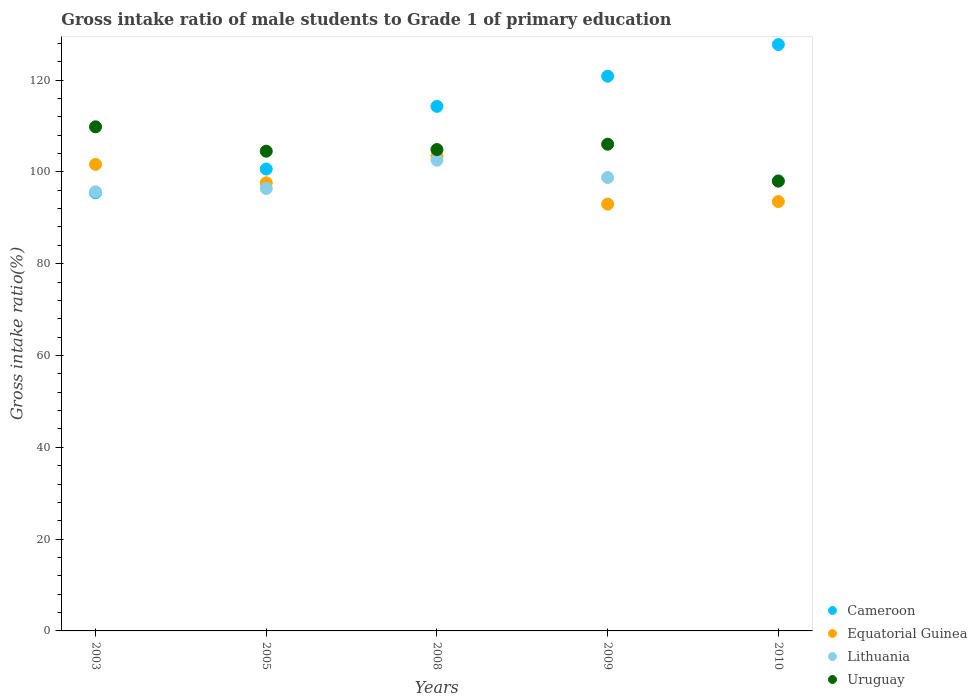How many different coloured dotlines are there?
Keep it short and to the point. 4. Is the number of dotlines equal to the number of legend labels?
Keep it short and to the point. Yes. What is the gross intake ratio in Cameroon in 2009?
Offer a very short reply. 120.85. Across all years, what is the maximum gross intake ratio in Cameroon?
Give a very brief answer. 127.74. Across all years, what is the minimum gross intake ratio in Uruguay?
Make the answer very short. 97.98. In which year was the gross intake ratio in Equatorial Guinea maximum?
Ensure brevity in your answer.  2008. In which year was the gross intake ratio in Uruguay minimum?
Your response must be concise. 2010. What is the total gross intake ratio in Cameroon in the graph?
Your answer should be very brief. 558.94. What is the difference between the gross intake ratio in Lithuania in 2008 and that in 2009?
Provide a short and direct response. 3.78. What is the difference between the gross intake ratio in Lithuania in 2005 and the gross intake ratio in Equatorial Guinea in 2010?
Provide a succinct answer. 2.85. What is the average gross intake ratio in Uruguay per year?
Keep it short and to the point. 104.64. In the year 2010, what is the difference between the gross intake ratio in Equatorial Guinea and gross intake ratio in Uruguay?
Provide a short and direct response. -4.45. In how many years, is the gross intake ratio in Lithuania greater than 80 %?
Your response must be concise. 5. What is the ratio of the gross intake ratio in Equatorial Guinea in 2008 to that in 2009?
Your answer should be compact. 1.11. Is the gross intake ratio in Uruguay in 2003 less than that in 2009?
Make the answer very short. No. Is the difference between the gross intake ratio in Equatorial Guinea in 2005 and 2008 greater than the difference between the gross intake ratio in Uruguay in 2005 and 2008?
Keep it short and to the point. No. What is the difference between the highest and the second highest gross intake ratio in Lithuania?
Keep it short and to the point. 3.78. What is the difference between the highest and the lowest gross intake ratio in Equatorial Guinea?
Offer a very short reply. 10.49. In how many years, is the gross intake ratio in Uruguay greater than the average gross intake ratio in Uruguay taken over all years?
Ensure brevity in your answer.  3. Is the sum of the gross intake ratio in Cameroon in 2003 and 2009 greater than the maximum gross intake ratio in Equatorial Guinea across all years?
Give a very brief answer. Yes. Is it the case that in every year, the sum of the gross intake ratio in Uruguay and gross intake ratio in Lithuania  is greater than the sum of gross intake ratio in Cameroon and gross intake ratio in Equatorial Guinea?
Your answer should be very brief. No. Is it the case that in every year, the sum of the gross intake ratio in Lithuania and gross intake ratio in Uruguay  is greater than the gross intake ratio in Cameroon?
Make the answer very short. Yes. How many dotlines are there?
Give a very brief answer. 4. Are the values on the major ticks of Y-axis written in scientific E-notation?
Your answer should be compact. No. Does the graph contain any zero values?
Ensure brevity in your answer.  No. Does the graph contain grids?
Your response must be concise. No. Where does the legend appear in the graph?
Make the answer very short. Bottom right. How many legend labels are there?
Offer a very short reply. 4. What is the title of the graph?
Offer a very short reply. Gross intake ratio of male students to Grade 1 of primary education. What is the label or title of the X-axis?
Offer a very short reply. Years. What is the label or title of the Y-axis?
Keep it short and to the point. Gross intake ratio(%). What is the Gross intake ratio(%) of Cameroon in 2003?
Keep it short and to the point. 95.46. What is the Gross intake ratio(%) of Equatorial Guinea in 2003?
Offer a terse response. 101.63. What is the Gross intake ratio(%) in Lithuania in 2003?
Your answer should be compact. 95.67. What is the Gross intake ratio(%) of Uruguay in 2003?
Your response must be concise. 109.82. What is the Gross intake ratio(%) in Cameroon in 2005?
Provide a short and direct response. 100.62. What is the Gross intake ratio(%) of Equatorial Guinea in 2005?
Give a very brief answer. 97.62. What is the Gross intake ratio(%) in Lithuania in 2005?
Give a very brief answer. 96.38. What is the Gross intake ratio(%) in Uruguay in 2005?
Provide a short and direct response. 104.5. What is the Gross intake ratio(%) in Cameroon in 2008?
Ensure brevity in your answer.  114.27. What is the Gross intake ratio(%) of Equatorial Guinea in 2008?
Ensure brevity in your answer.  103.47. What is the Gross intake ratio(%) in Lithuania in 2008?
Ensure brevity in your answer.  102.55. What is the Gross intake ratio(%) of Uruguay in 2008?
Your answer should be very brief. 104.86. What is the Gross intake ratio(%) of Cameroon in 2009?
Your response must be concise. 120.85. What is the Gross intake ratio(%) in Equatorial Guinea in 2009?
Offer a terse response. 92.97. What is the Gross intake ratio(%) of Lithuania in 2009?
Offer a terse response. 98.77. What is the Gross intake ratio(%) in Uruguay in 2009?
Make the answer very short. 106.03. What is the Gross intake ratio(%) of Cameroon in 2010?
Ensure brevity in your answer.  127.74. What is the Gross intake ratio(%) of Equatorial Guinea in 2010?
Ensure brevity in your answer.  93.54. What is the Gross intake ratio(%) in Lithuania in 2010?
Your answer should be compact. 98.09. What is the Gross intake ratio(%) of Uruguay in 2010?
Make the answer very short. 97.98. Across all years, what is the maximum Gross intake ratio(%) of Cameroon?
Offer a terse response. 127.74. Across all years, what is the maximum Gross intake ratio(%) of Equatorial Guinea?
Give a very brief answer. 103.47. Across all years, what is the maximum Gross intake ratio(%) of Lithuania?
Provide a short and direct response. 102.55. Across all years, what is the maximum Gross intake ratio(%) in Uruguay?
Keep it short and to the point. 109.82. Across all years, what is the minimum Gross intake ratio(%) of Cameroon?
Offer a very short reply. 95.46. Across all years, what is the minimum Gross intake ratio(%) in Equatorial Guinea?
Provide a succinct answer. 92.97. Across all years, what is the minimum Gross intake ratio(%) of Lithuania?
Give a very brief answer. 95.67. Across all years, what is the minimum Gross intake ratio(%) in Uruguay?
Offer a terse response. 97.98. What is the total Gross intake ratio(%) in Cameroon in the graph?
Provide a succinct answer. 558.94. What is the total Gross intake ratio(%) in Equatorial Guinea in the graph?
Your answer should be very brief. 489.22. What is the total Gross intake ratio(%) of Lithuania in the graph?
Your response must be concise. 491.46. What is the total Gross intake ratio(%) of Uruguay in the graph?
Offer a terse response. 523.2. What is the difference between the Gross intake ratio(%) in Cameroon in 2003 and that in 2005?
Offer a terse response. -5.16. What is the difference between the Gross intake ratio(%) of Equatorial Guinea in 2003 and that in 2005?
Provide a succinct answer. 4.01. What is the difference between the Gross intake ratio(%) in Lithuania in 2003 and that in 2005?
Provide a short and direct response. -0.71. What is the difference between the Gross intake ratio(%) of Uruguay in 2003 and that in 2005?
Your answer should be very brief. 5.31. What is the difference between the Gross intake ratio(%) of Cameroon in 2003 and that in 2008?
Ensure brevity in your answer.  -18.81. What is the difference between the Gross intake ratio(%) in Equatorial Guinea in 2003 and that in 2008?
Your answer should be compact. -1.84. What is the difference between the Gross intake ratio(%) in Lithuania in 2003 and that in 2008?
Give a very brief answer. -6.88. What is the difference between the Gross intake ratio(%) of Uruguay in 2003 and that in 2008?
Give a very brief answer. 4.95. What is the difference between the Gross intake ratio(%) of Cameroon in 2003 and that in 2009?
Your answer should be compact. -25.38. What is the difference between the Gross intake ratio(%) in Equatorial Guinea in 2003 and that in 2009?
Give a very brief answer. 8.65. What is the difference between the Gross intake ratio(%) in Lithuania in 2003 and that in 2009?
Provide a succinct answer. -3.1. What is the difference between the Gross intake ratio(%) of Uruguay in 2003 and that in 2009?
Provide a short and direct response. 3.79. What is the difference between the Gross intake ratio(%) of Cameroon in 2003 and that in 2010?
Keep it short and to the point. -32.28. What is the difference between the Gross intake ratio(%) of Equatorial Guinea in 2003 and that in 2010?
Provide a succinct answer. 8.09. What is the difference between the Gross intake ratio(%) in Lithuania in 2003 and that in 2010?
Provide a succinct answer. -2.42. What is the difference between the Gross intake ratio(%) in Uruguay in 2003 and that in 2010?
Your answer should be very brief. 11.83. What is the difference between the Gross intake ratio(%) of Cameroon in 2005 and that in 2008?
Ensure brevity in your answer.  -13.65. What is the difference between the Gross intake ratio(%) in Equatorial Guinea in 2005 and that in 2008?
Provide a succinct answer. -5.85. What is the difference between the Gross intake ratio(%) of Lithuania in 2005 and that in 2008?
Provide a succinct answer. -6.17. What is the difference between the Gross intake ratio(%) of Uruguay in 2005 and that in 2008?
Provide a succinct answer. -0.36. What is the difference between the Gross intake ratio(%) of Cameroon in 2005 and that in 2009?
Provide a short and direct response. -20.22. What is the difference between the Gross intake ratio(%) of Equatorial Guinea in 2005 and that in 2009?
Make the answer very short. 4.64. What is the difference between the Gross intake ratio(%) in Lithuania in 2005 and that in 2009?
Ensure brevity in your answer.  -2.39. What is the difference between the Gross intake ratio(%) of Uruguay in 2005 and that in 2009?
Give a very brief answer. -1.52. What is the difference between the Gross intake ratio(%) in Cameroon in 2005 and that in 2010?
Your response must be concise. -27.12. What is the difference between the Gross intake ratio(%) of Equatorial Guinea in 2005 and that in 2010?
Offer a very short reply. 4.08. What is the difference between the Gross intake ratio(%) in Lithuania in 2005 and that in 2010?
Offer a terse response. -1.71. What is the difference between the Gross intake ratio(%) in Uruguay in 2005 and that in 2010?
Your answer should be very brief. 6.52. What is the difference between the Gross intake ratio(%) in Cameroon in 2008 and that in 2009?
Offer a terse response. -6.58. What is the difference between the Gross intake ratio(%) in Equatorial Guinea in 2008 and that in 2009?
Your answer should be compact. 10.49. What is the difference between the Gross intake ratio(%) of Lithuania in 2008 and that in 2009?
Keep it short and to the point. 3.78. What is the difference between the Gross intake ratio(%) of Uruguay in 2008 and that in 2009?
Provide a succinct answer. -1.16. What is the difference between the Gross intake ratio(%) in Cameroon in 2008 and that in 2010?
Your response must be concise. -13.47. What is the difference between the Gross intake ratio(%) in Equatorial Guinea in 2008 and that in 2010?
Provide a short and direct response. 9.93. What is the difference between the Gross intake ratio(%) in Lithuania in 2008 and that in 2010?
Keep it short and to the point. 4.46. What is the difference between the Gross intake ratio(%) in Uruguay in 2008 and that in 2010?
Your answer should be compact. 6.88. What is the difference between the Gross intake ratio(%) in Cameroon in 2009 and that in 2010?
Your answer should be compact. -6.89. What is the difference between the Gross intake ratio(%) of Equatorial Guinea in 2009 and that in 2010?
Your answer should be compact. -0.56. What is the difference between the Gross intake ratio(%) in Lithuania in 2009 and that in 2010?
Make the answer very short. 0.68. What is the difference between the Gross intake ratio(%) of Uruguay in 2009 and that in 2010?
Offer a very short reply. 8.04. What is the difference between the Gross intake ratio(%) in Cameroon in 2003 and the Gross intake ratio(%) in Equatorial Guinea in 2005?
Your response must be concise. -2.16. What is the difference between the Gross intake ratio(%) in Cameroon in 2003 and the Gross intake ratio(%) in Lithuania in 2005?
Offer a very short reply. -0.92. What is the difference between the Gross intake ratio(%) of Cameroon in 2003 and the Gross intake ratio(%) of Uruguay in 2005?
Make the answer very short. -9.04. What is the difference between the Gross intake ratio(%) of Equatorial Guinea in 2003 and the Gross intake ratio(%) of Lithuania in 2005?
Offer a terse response. 5.25. What is the difference between the Gross intake ratio(%) of Equatorial Guinea in 2003 and the Gross intake ratio(%) of Uruguay in 2005?
Provide a short and direct response. -2.88. What is the difference between the Gross intake ratio(%) in Lithuania in 2003 and the Gross intake ratio(%) in Uruguay in 2005?
Make the answer very short. -8.83. What is the difference between the Gross intake ratio(%) in Cameroon in 2003 and the Gross intake ratio(%) in Equatorial Guinea in 2008?
Ensure brevity in your answer.  -8. What is the difference between the Gross intake ratio(%) of Cameroon in 2003 and the Gross intake ratio(%) of Lithuania in 2008?
Your response must be concise. -7.09. What is the difference between the Gross intake ratio(%) in Cameroon in 2003 and the Gross intake ratio(%) in Uruguay in 2008?
Your answer should be very brief. -9.4. What is the difference between the Gross intake ratio(%) in Equatorial Guinea in 2003 and the Gross intake ratio(%) in Lithuania in 2008?
Provide a short and direct response. -0.92. What is the difference between the Gross intake ratio(%) of Equatorial Guinea in 2003 and the Gross intake ratio(%) of Uruguay in 2008?
Offer a terse response. -3.24. What is the difference between the Gross intake ratio(%) of Lithuania in 2003 and the Gross intake ratio(%) of Uruguay in 2008?
Your answer should be very brief. -9.19. What is the difference between the Gross intake ratio(%) of Cameroon in 2003 and the Gross intake ratio(%) of Equatorial Guinea in 2009?
Offer a very short reply. 2.49. What is the difference between the Gross intake ratio(%) of Cameroon in 2003 and the Gross intake ratio(%) of Lithuania in 2009?
Ensure brevity in your answer.  -3.31. What is the difference between the Gross intake ratio(%) of Cameroon in 2003 and the Gross intake ratio(%) of Uruguay in 2009?
Provide a short and direct response. -10.57. What is the difference between the Gross intake ratio(%) of Equatorial Guinea in 2003 and the Gross intake ratio(%) of Lithuania in 2009?
Give a very brief answer. 2.86. What is the difference between the Gross intake ratio(%) in Equatorial Guinea in 2003 and the Gross intake ratio(%) in Uruguay in 2009?
Provide a succinct answer. -4.4. What is the difference between the Gross intake ratio(%) of Lithuania in 2003 and the Gross intake ratio(%) of Uruguay in 2009?
Ensure brevity in your answer.  -10.36. What is the difference between the Gross intake ratio(%) of Cameroon in 2003 and the Gross intake ratio(%) of Equatorial Guinea in 2010?
Keep it short and to the point. 1.93. What is the difference between the Gross intake ratio(%) of Cameroon in 2003 and the Gross intake ratio(%) of Lithuania in 2010?
Provide a short and direct response. -2.62. What is the difference between the Gross intake ratio(%) in Cameroon in 2003 and the Gross intake ratio(%) in Uruguay in 2010?
Give a very brief answer. -2.52. What is the difference between the Gross intake ratio(%) in Equatorial Guinea in 2003 and the Gross intake ratio(%) in Lithuania in 2010?
Provide a succinct answer. 3.54. What is the difference between the Gross intake ratio(%) of Equatorial Guinea in 2003 and the Gross intake ratio(%) of Uruguay in 2010?
Make the answer very short. 3.64. What is the difference between the Gross intake ratio(%) of Lithuania in 2003 and the Gross intake ratio(%) of Uruguay in 2010?
Offer a very short reply. -2.31. What is the difference between the Gross intake ratio(%) of Cameroon in 2005 and the Gross intake ratio(%) of Equatorial Guinea in 2008?
Your answer should be very brief. -2.85. What is the difference between the Gross intake ratio(%) in Cameroon in 2005 and the Gross intake ratio(%) in Lithuania in 2008?
Provide a succinct answer. -1.93. What is the difference between the Gross intake ratio(%) of Cameroon in 2005 and the Gross intake ratio(%) of Uruguay in 2008?
Your response must be concise. -4.24. What is the difference between the Gross intake ratio(%) of Equatorial Guinea in 2005 and the Gross intake ratio(%) of Lithuania in 2008?
Provide a short and direct response. -4.93. What is the difference between the Gross intake ratio(%) of Equatorial Guinea in 2005 and the Gross intake ratio(%) of Uruguay in 2008?
Your response must be concise. -7.25. What is the difference between the Gross intake ratio(%) in Lithuania in 2005 and the Gross intake ratio(%) in Uruguay in 2008?
Offer a very short reply. -8.48. What is the difference between the Gross intake ratio(%) in Cameroon in 2005 and the Gross intake ratio(%) in Equatorial Guinea in 2009?
Provide a short and direct response. 7.65. What is the difference between the Gross intake ratio(%) in Cameroon in 2005 and the Gross intake ratio(%) in Lithuania in 2009?
Keep it short and to the point. 1.85. What is the difference between the Gross intake ratio(%) in Cameroon in 2005 and the Gross intake ratio(%) in Uruguay in 2009?
Give a very brief answer. -5.41. What is the difference between the Gross intake ratio(%) in Equatorial Guinea in 2005 and the Gross intake ratio(%) in Lithuania in 2009?
Give a very brief answer. -1.15. What is the difference between the Gross intake ratio(%) of Equatorial Guinea in 2005 and the Gross intake ratio(%) of Uruguay in 2009?
Provide a succinct answer. -8.41. What is the difference between the Gross intake ratio(%) in Lithuania in 2005 and the Gross intake ratio(%) in Uruguay in 2009?
Your response must be concise. -9.65. What is the difference between the Gross intake ratio(%) of Cameroon in 2005 and the Gross intake ratio(%) of Equatorial Guinea in 2010?
Provide a short and direct response. 7.09. What is the difference between the Gross intake ratio(%) in Cameroon in 2005 and the Gross intake ratio(%) in Lithuania in 2010?
Offer a very short reply. 2.53. What is the difference between the Gross intake ratio(%) in Cameroon in 2005 and the Gross intake ratio(%) in Uruguay in 2010?
Give a very brief answer. 2.64. What is the difference between the Gross intake ratio(%) in Equatorial Guinea in 2005 and the Gross intake ratio(%) in Lithuania in 2010?
Your response must be concise. -0.47. What is the difference between the Gross intake ratio(%) of Equatorial Guinea in 2005 and the Gross intake ratio(%) of Uruguay in 2010?
Offer a very short reply. -0.36. What is the difference between the Gross intake ratio(%) in Lithuania in 2005 and the Gross intake ratio(%) in Uruguay in 2010?
Offer a terse response. -1.6. What is the difference between the Gross intake ratio(%) of Cameroon in 2008 and the Gross intake ratio(%) of Equatorial Guinea in 2009?
Provide a succinct answer. 21.29. What is the difference between the Gross intake ratio(%) in Cameroon in 2008 and the Gross intake ratio(%) in Lithuania in 2009?
Offer a terse response. 15.5. What is the difference between the Gross intake ratio(%) in Cameroon in 2008 and the Gross intake ratio(%) in Uruguay in 2009?
Your answer should be very brief. 8.24. What is the difference between the Gross intake ratio(%) in Equatorial Guinea in 2008 and the Gross intake ratio(%) in Lithuania in 2009?
Provide a short and direct response. 4.7. What is the difference between the Gross intake ratio(%) in Equatorial Guinea in 2008 and the Gross intake ratio(%) in Uruguay in 2009?
Keep it short and to the point. -2.56. What is the difference between the Gross intake ratio(%) in Lithuania in 2008 and the Gross intake ratio(%) in Uruguay in 2009?
Keep it short and to the point. -3.48. What is the difference between the Gross intake ratio(%) in Cameroon in 2008 and the Gross intake ratio(%) in Equatorial Guinea in 2010?
Offer a terse response. 20.73. What is the difference between the Gross intake ratio(%) in Cameroon in 2008 and the Gross intake ratio(%) in Lithuania in 2010?
Your answer should be very brief. 16.18. What is the difference between the Gross intake ratio(%) of Cameroon in 2008 and the Gross intake ratio(%) of Uruguay in 2010?
Your answer should be compact. 16.29. What is the difference between the Gross intake ratio(%) in Equatorial Guinea in 2008 and the Gross intake ratio(%) in Lithuania in 2010?
Offer a very short reply. 5.38. What is the difference between the Gross intake ratio(%) in Equatorial Guinea in 2008 and the Gross intake ratio(%) in Uruguay in 2010?
Make the answer very short. 5.48. What is the difference between the Gross intake ratio(%) in Lithuania in 2008 and the Gross intake ratio(%) in Uruguay in 2010?
Keep it short and to the point. 4.57. What is the difference between the Gross intake ratio(%) of Cameroon in 2009 and the Gross intake ratio(%) of Equatorial Guinea in 2010?
Provide a succinct answer. 27.31. What is the difference between the Gross intake ratio(%) of Cameroon in 2009 and the Gross intake ratio(%) of Lithuania in 2010?
Provide a short and direct response. 22.76. What is the difference between the Gross intake ratio(%) of Cameroon in 2009 and the Gross intake ratio(%) of Uruguay in 2010?
Provide a succinct answer. 22.86. What is the difference between the Gross intake ratio(%) of Equatorial Guinea in 2009 and the Gross intake ratio(%) of Lithuania in 2010?
Provide a succinct answer. -5.11. What is the difference between the Gross intake ratio(%) in Equatorial Guinea in 2009 and the Gross intake ratio(%) in Uruguay in 2010?
Ensure brevity in your answer.  -5.01. What is the difference between the Gross intake ratio(%) of Lithuania in 2009 and the Gross intake ratio(%) of Uruguay in 2010?
Make the answer very short. 0.79. What is the average Gross intake ratio(%) in Cameroon per year?
Provide a succinct answer. 111.79. What is the average Gross intake ratio(%) in Equatorial Guinea per year?
Give a very brief answer. 97.84. What is the average Gross intake ratio(%) in Lithuania per year?
Ensure brevity in your answer.  98.29. What is the average Gross intake ratio(%) in Uruguay per year?
Ensure brevity in your answer.  104.64. In the year 2003, what is the difference between the Gross intake ratio(%) in Cameroon and Gross intake ratio(%) in Equatorial Guinea?
Your response must be concise. -6.17. In the year 2003, what is the difference between the Gross intake ratio(%) in Cameroon and Gross intake ratio(%) in Lithuania?
Ensure brevity in your answer.  -0.21. In the year 2003, what is the difference between the Gross intake ratio(%) of Cameroon and Gross intake ratio(%) of Uruguay?
Keep it short and to the point. -14.35. In the year 2003, what is the difference between the Gross intake ratio(%) in Equatorial Guinea and Gross intake ratio(%) in Lithuania?
Ensure brevity in your answer.  5.96. In the year 2003, what is the difference between the Gross intake ratio(%) in Equatorial Guinea and Gross intake ratio(%) in Uruguay?
Your answer should be compact. -8.19. In the year 2003, what is the difference between the Gross intake ratio(%) in Lithuania and Gross intake ratio(%) in Uruguay?
Give a very brief answer. -14.15. In the year 2005, what is the difference between the Gross intake ratio(%) in Cameroon and Gross intake ratio(%) in Equatorial Guinea?
Offer a terse response. 3. In the year 2005, what is the difference between the Gross intake ratio(%) in Cameroon and Gross intake ratio(%) in Lithuania?
Your answer should be very brief. 4.24. In the year 2005, what is the difference between the Gross intake ratio(%) in Cameroon and Gross intake ratio(%) in Uruguay?
Provide a short and direct response. -3.88. In the year 2005, what is the difference between the Gross intake ratio(%) of Equatorial Guinea and Gross intake ratio(%) of Lithuania?
Your answer should be very brief. 1.24. In the year 2005, what is the difference between the Gross intake ratio(%) in Equatorial Guinea and Gross intake ratio(%) in Uruguay?
Your response must be concise. -6.89. In the year 2005, what is the difference between the Gross intake ratio(%) in Lithuania and Gross intake ratio(%) in Uruguay?
Keep it short and to the point. -8.12. In the year 2008, what is the difference between the Gross intake ratio(%) in Cameroon and Gross intake ratio(%) in Equatorial Guinea?
Provide a short and direct response. 10.8. In the year 2008, what is the difference between the Gross intake ratio(%) of Cameroon and Gross intake ratio(%) of Lithuania?
Keep it short and to the point. 11.72. In the year 2008, what is the difference between the Gross intake ratio(%) in Cameroon and Gross intake ratio(%) in Uruguay?
Ensure brevity in your answer.  9.41. In the year 2008, what is the difference between the Gross intake ratio(%) of Equatorial Guinea and Gross intake ratio(%) of Lithuania?
Provide a succinct answer. 0.92. In the year 2008, what is the difference between the Gross intake ratio(%) of Equatorial Guinea and Gross intake ratio(%) of Uruguay?
Your response must be concise. -1.4. In the year 2008, what is the difference between the Gross intake ratio(%) of Lithuania and Gross intake ratio(%) of Uruguay?
Offer a very short reply. -2.31. In the year 2009, what is the difference between the Gross intake ratio(%) of Cameroon and Gross intake ratio(%) of Equatorial Guinea?
Ensure brevity in your answer.  27.87. In the year 2009, what is the difference between the Gross intake ratio(%) of Cameroon and Gross intake ratio(%) of Lithuania?
Ensure brevity in your answer.  22.07. In the year 2009, what is the difference between the Gross intake ratio(%) in Cameroon and Gross intake ratio(%) in Uruguay?
Provide a short and direct response. 14.82. In the year 2009, what is the difference between the Gross intake ratio(%) in Equatorial Guinea and Gross intake ratio(%) in Lithuania?
Give a very brief answer. -5.8. In the year 2009, what is the difference between the Gross intake ratio(%) of Equatorial Guinea and Gross intake ratio(%) of Uruguay?
Your answer should be compact. -13.05. In the year 2009, what is the difference between the Gross intake ratio(%) in Lithuania and Gross intake ratio(%) in Uruguay?
Keep it short and to the point. -7.26. In the year 2010, what is the difference between the Gross intake ratio(%) in Cameroon and Gross intake ratio(%) in Equatorial Guinea?
Keep it short and to the point. 34.2. In the year 2010, what is the difference between the Gross intake ratio(%) of Cameroon and Gross intake ratio(%) of Lithuania?
Offer a terse response. 29.65. In the year 2010, what is the difference between the Gross intake ratio(%) in Cameroon and Gross intake ratio(%) in Uruguay?
Offer a terse response. 29.75. In the year 2010, what is the difference between the Gross intake ratio(%) of Equatorial Guinea and Gross intake ratio(%) of Lithuania?
Make the answer very short. -4.55. In the year 2010, what is the difference between the Gross intake ratio(%) in Equatorial Guinea and Gross intake ratio(%) in Uruguay?
Your response must be concise. -4.45. In the year 2010, what is the difference between the Gross intake ratio(%) in Lithuania and Gross intake ratio(%) in Uruguay?
Provide a short and direct response. 0.1. What is the ratio of the Gross intake ratio(%) in Cameroon in 2003 to that in 2005?
Offer a very short reply. 0.95. What is the ratio of the Gross intake ratio(%) of Equatorial Guinea in 2003 to that in 2005?
Offer a terse response. 1.04. What is the ratio of the Gross intake ratio(%) of Uruguay in 2003 to that in 2005?
Provide a succinct answer. 1.05. What is the ratio of the Gross intake ratio(%) in Cameroon in 2003 to that in 2008?
Provide a succinct answer. 0.84. What is the ratio of the Gross intake ratio(%) in Equatorial Guinea in 2003 to that in 2008?
Your answer should be compact. 0.98. What is the ratio of the Gross intake ratio(%) in Lithuania in 2003 to that in 2008?
Provide a short and direct response. 0.93. What is the ratio of the Gross intake ratio(%) in Uruguay in 2003 to that in 2008?
Your answer should be very brief. 1.05. What is the ratio of the Gross intake ratio(%) in Cameroon in 2003 to that in 2009?
Your answer should be very brief. 0.79. What is the ratio of the Gross intake ratio(%) of Equatorial Guinea in 2003 to that in 2009?
Offer a very short reply. 1.09. What is the ratio of the Gross intake ratio(%) of Lithuania in 2003 to that in 2009?
Your response must be concise. 0.97. What is the ratio of the Gross intake ratio(%) of Uruguay in 2003 to that in 2009?
Offer a terse response. 1.04. What is the ratio of the Gross intake ratio(%) of Cameroon in 2003 to that in 2010?
Make the answer very short. 0.75. What is the ratio of the Gross intake ratio(%) in Equatorial Guinea in 2003 to that in 2010?
Provide a succinct answer. 1.09. What is the ratio of the Gross intake ratio(%) of Lithuania in 2003 to that in 2010?
Offer a very short reply. 0.98. What is the ratio of the Gross intake ratio(%) in Uruguay in 2003 to that in 2010?
Keep it short and to the point. 1.12. What is the ratio of the Gross intake ratio(%) in Cameroon in 2005 to that in 2008?
Provide a succinct answer. 0.88. What is the ratio of the Gross intake ratio(%) of Equatorial Guinea in 2005 to that in 2008?
Offer a very short reply. 0.94. What is the ratio of the Gross intake ratio(%) of Lithuania in 2005 to that in 2008?
Ensure brevity in your answer.  0.94. What is the ratio of the Gross intake ratio(%) of Cameroon in 2005 to that in 2009?
Your answer should be very brief. 0.83. What is the ratio of the Gross intake ratio(%) in Equatorial Guinea in 2005 to that in 2009?
Give a very brief answer. 1.05. What is the ratio of the Gross intake ratio(%) in Lithuania in 2005 to that in 2009?
Keep it short and to the point. 0.98. What is the ratio of the Gross intake ratio(%) of Uruguay in 2005 to that in 2009?
Provide a short and direct response. 0.99. What is the ratio of the Gross intake ratio(%) of Cameroon in 2005 to that in 2010?
Keep it short and to the point. 0.79. What is the ratio of the Gross intake ratio(%) of Equatorial Guinea in 2005 to that in 2010?
Give a very brief answer. 1.04. What is the ratio of the Gross intake ratio(%) in Lithuania in 2005 to that in 2010?
Provide a succinct answer. 0.98. What is the ratio of the Gross intake ratio(%) in Uruguay in 2005 to that in 2010?
Provide a short and direct response. 1.07. What is the ratio of the Gross intake ratio(%) of Cameroon in 2008 to that in 2009?
Give a very brief answer. 0.95. What is the ratio of the Gross intake ratio(%) of Equatorial Guinea in 2008 to that in 2009?
Ensure brevity in your answer.  1.11. What is the ratio of the Gross intake ratio(%) in Lithuania in 2008 to that in 2009?
Provide a short and direct response. 1.04. What is the ratio of the Gross intake ratio(%) of Cameroon in 2008 to that in 2010?
Ensure brevity in your answer.  0.89. What is the ratio of the Gross intake ratio(%) of Equatorial Guinea in 2008 to that in 2010?
Offer a very short reply. 1.11. What is the ratio of the Gross intake ratio(%) in Lithuania in 2008 to that in 2010?
Offer a terse response. 1.05. What is the ratio of the Gross intake ratio(%) in Uruguay in 2008 to that in 2010?
Give a very brief answer. 1.07. What is the ratio of the Gross intake ratio(%) in Cameroon in 2009 to that in 2010?
Provide a succinct answer. 0.95. What is the ratio of the Gross intake ratio(%) of Equatorial Guinea in 2009 to that in 2010?
Your response must be concise. 0.99. What is the ratio of the Gross intake ratio(%) in Uruguay in 2009 to that in 2010?
Make the answer very short. 1.08. What is the difference between the highest and the second highest Gross intake ratio(%) of Cameroon?
Provide a succinct answer. 6.89. What is the difference between the highest and the second highest Gross intake ratio(%) in Equatorial Guinea?
Ensure brevity in your answer.  1.84. What is the difference between the highest and the second highest Gross intake ratio(%) of Lithuania?
Your answer should be compact. 3.78. What is the difference between the highest and the second highest Gross intake ratio(%) of Uruguay?
Your answer should be compact. 3.79. What is the difference between the highest and the lowest Gross intake ratio(%) in Cameroon?
Provide a succinct answer. 32.28. What is the difference between the highest and the lowest Gross intake ratio(%) in Equatorial Guinea?
Your answer should be compact. 10.49. What is the difference between the highest and the lowest Gross intake ratio(%) of Lithuania?
Give a very brief answer. 6.88. What is the difference between the highest and the lowest Gross intake ratio(%) in Uruguay?
Ensure brevity in your answer.  11.83. 